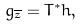Convert formula to latex. <formula><loc_0><loc_0><loc_500><loc_500>g _ { \overline { z } } = T ^ { * } h ,</formula> 